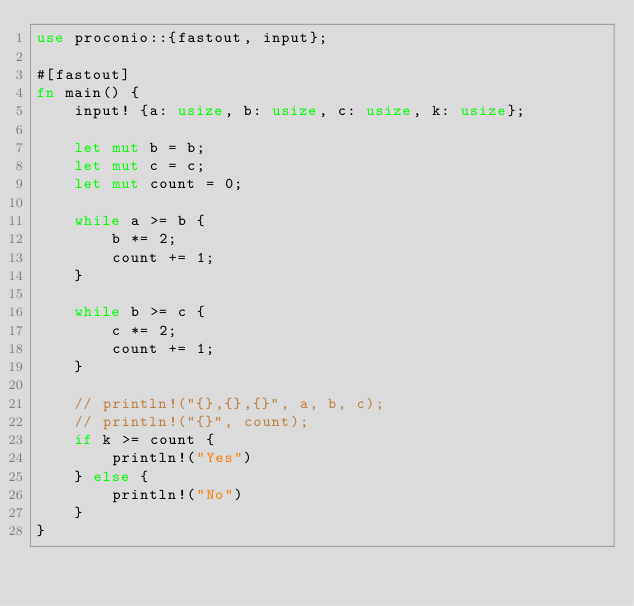Convert code to text. <code><loc_0><loc_0><loc_500><loc_500><_Rust_>use proconio::{fastout, input};

#[fastout]
fn main() {
    input! {a: usize, b: usize, c: usize, k: usize};

    let mut b = b;
    let mut c = c;
    let mut count = 0;

    while a >= b {
        b *= 2;
        count += 1;
    }

    while b >= c {
        c *= 2;
        count += 1;
    }

    // println!("{},{},{}", a, b, c);
    // println!("{}", count);
    if k >= count {
        println!("Yes")
    } else {
        println!("No")
    }
}
</code> 